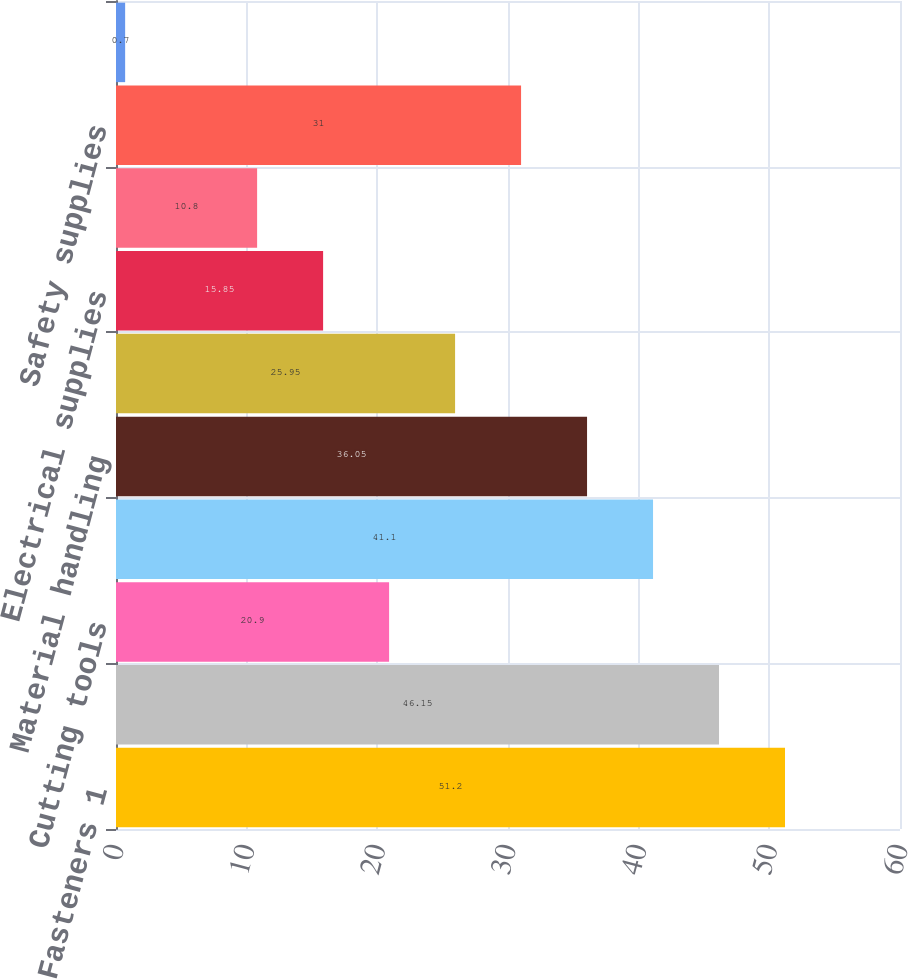<chart> <loc_0><loc_0><loc_500><loc_500><bar_chart><fcel>Fasteners 1<fcel>Tools<fcel>Cutting tools<fcel>Hydraulics & pneumatics<fcel>Material handling<fcel>Janitorial supplies<fcel>Electrical supplies<fcel>Welding supplies<fcel>Safety supplies<fcel>Metals<nl><fcel>51.2<fcel>46.15<fcel>20.9<fcel>41.1<fcel>36.05<fcel>25.95<fcel>15.85<fcel>10.8<fcel>31<fcel>0.7<nl></chart> 